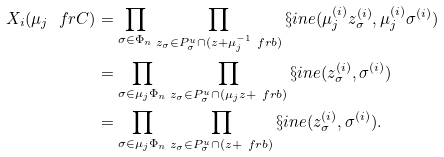Convert formula to latex. <formula><loc_0><loc_0><loc_500><loc_500>X _ { i } ( \mu _ { j } \ f r C ) & = \prod _ { \sigma \in \Phi _ { n } } \prod _ { z _ { \sigma } \in P ^ { u } _ { \sigma } \cap ( z + \mu _ { j } ^ { - 1 } \ f r b ) } \S i n e ( \mu _ { j } ^ { ( i ) } z _ { \sigma } ^ { ( i ) } , \mu _ { j } ^ { ( i ) } \sigma ^ { ( i ) } ) \\ & = \prod _ { \sigma \in \mu _ { j } \Phi _ { n } } \prod _ { z _ { \sigma } \in P ^ { u } _ { \sigma } \cap ( \mu _ { j } z + \ f r b ) } \S i n e ( z _ { \sigma } ^ { ( i ) } , \sigma ^ { ( i ) } ) \\ & = \prod _ { \sigma \in \mu _ { j } \Phi _ { n } } \prod _ { z _ { \sigma } \in P ^ { u } _ { \sigma } \cap ( z + \ f r b ) } \S i n e ( z _ { \sigma } ^ { ( i ) } , \sigma ^ { ( i ) } ) .</formula> 